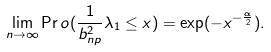<formula> <loc_0><loc_0><loc_500><loc_500>\lim _ { n \rightarrow \infty } \Pr o ( \frac { 1 } { b _ { n p } ^ { 2 } } \lambda _ { 1 } \leq x ) = \exp ( - x ^ { - \frac { \alpha } { 2 } } ) .</formula> 